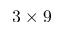Convert formula to latex. <formula><loc_0><loc_0><loc_500><loc_500>3 \times 9</formula> 